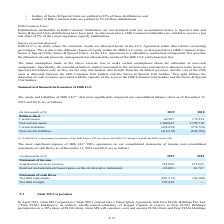From Golar Lng's financial document, In which years was the financial information recorded for? The document shows two values: 2019 and 2018. From the document: "(in thousands of $) 2019 2018 Balance sheet Current assets 64,507 172,554 (in thousands of $) 2019 2018 Balance sheet Current assets 64,507 172,554..." Also, What was the net debt receipts in 2019? According to the financial document, 129,454 (in thousands). The relevant text states: "Net debt receipts 129,454 —..." Also, What was the net debt repayments in 2018? According to the financial document, (30,300) (in thousands). The relevant text states: "tement of cash flows Net debt repayments (243,513) (30,300)..." Additionally, In which year was the realized and unrealized (losses)/gains on the oil derivative instrument higher? According to the financial document, 2018. The relevant text states: "(in thousands of $) 2019 2018 Balance sheet Current assets 64,507 172,554..." Also, can you calculate: What was the change in net debt receipts between 2018 and 2019? Based on the calculation: 129,454 - 0 , the result is 129454 (in thousands). This is based on the information: "Net debt receipts 129,454 — 2019 and 2018, are as follows:..." The key data points involved are: 0, 129,454. Also, can you calculate: What was the percentage change in liquefaction services revenue between 2018 and 2019? To answer this question, I need to perform calculations using the financial data. The calculation is: (218,096 - 127,625)/127,625 , which equals 70.89 (percentage). This is based on the information: "t of income Liquefaction services revenue 218,096 127,625 Statement of income Liquefaction services revenue 218,096 127,625..." The key data points involved are: 127,625, 218,096. 